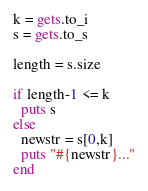<code> <loc_0><loc_0><loc_500><loc_500><_Ruby_>k = gets.to_i
s = gets.to_s

length = s.size

if length-1 <= k
  puts s
else
  newstr = s[0,k]
  puts "#{newstr}..."
end</code> 